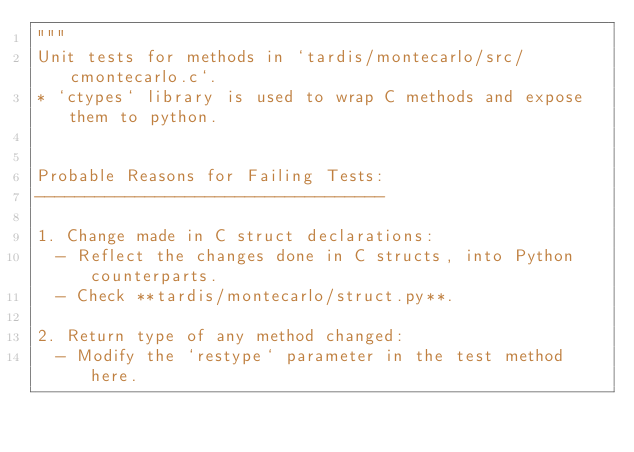<code> <loc_0><loc_0><loc_500><loc_500><_Python_>"""
Unit tests for methods in `tardis/montecarlo/src/cmontecarlo.c`.
* `ctypes` library is used to wrap C methods and expose them to python.


Probable Reasons for Failing Tests:
-----------------------------------

1. Change made in C struct declarations:
  - Reflect the changes done in C structs, into Python counterparts.
  - Check **tardis/montecarlo/struct.py**.

2. Return type of any method changed:
  - Modify the `restype` parameter in the test method here.</code> 